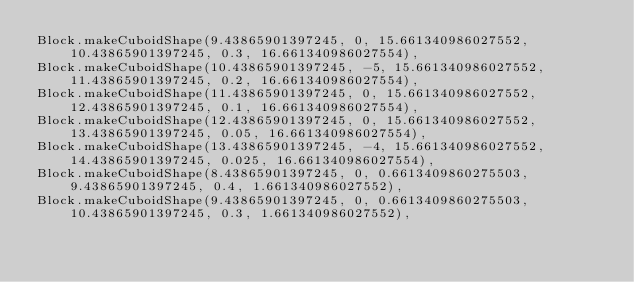<code> <loc_0><loc_0><loc_500><loc_500><_Java_>Block.makeCuboidShape(9.43865901397245, 0, 15.661340986027552, 10.43865901397245, 0.3, 16.661340986027554),
Block.makeCuboidShape(10.43865901397245, -5, 15.661340986027552, 11.43865901397245, 0.2, 16.661340986027554),
Block.makeCuboidShape(11.43865901397245, 0, 15.661340986027552, 12.43865901397245, 0.1, 16.661340986027554),
Block.makeCuboidShape(12.43865901397245, 0, 15.661340986027552, 13.43865901397245, 0.05, 16.661340986027554),
Block.makeCuboidShape(13.43865901397245, -4, 15.661340986027552, 14.43865901397245, 0.025, 16.661340986027554),
Block.makeCuboidShape(8.43865901397245, 0, 0.6613409860275503, 9.43865901397245, 0.4, 1.661340986027552),
Block.makeCuboidShape(9.43865901397245, 0, 0.6613409860275503, 10.43865901397245, 0.3, 1.661340986027552),</code> 